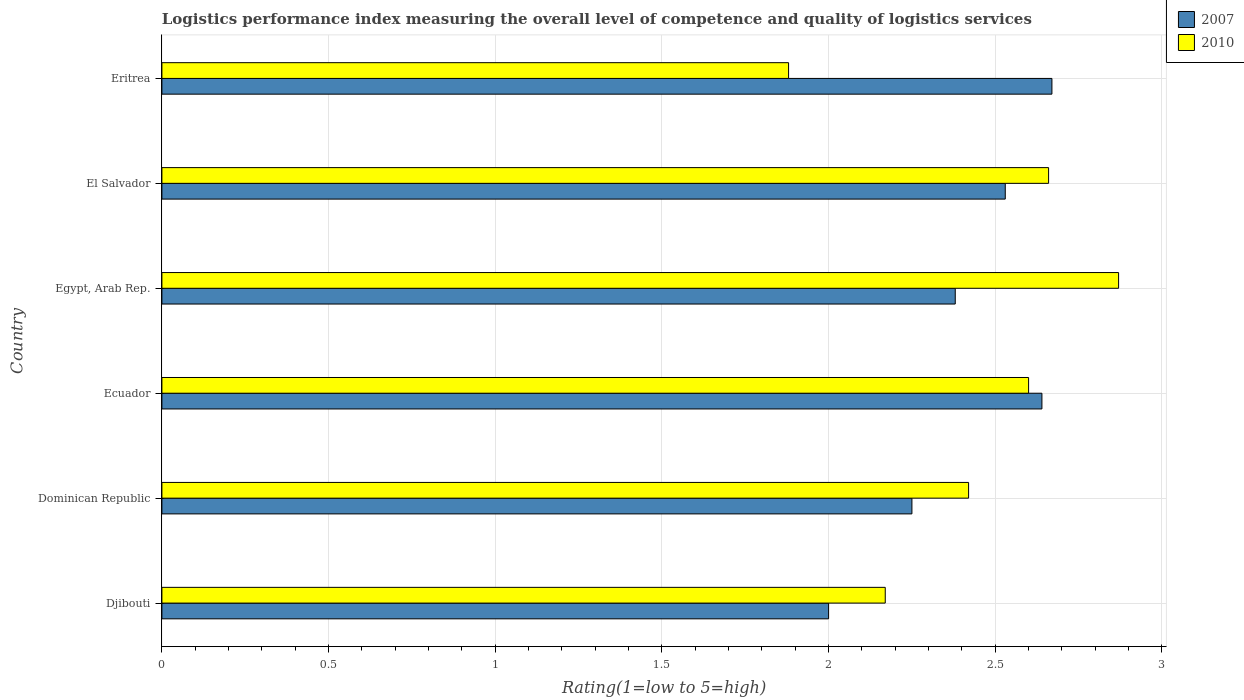How many bars are there on the 4th tick from the bottom?
Your response must be concise. 2. What is the label of the 2nd group of bars from the top?
Make the answer very short. El Salvador. In how many cases, is the number of bars for a given country not equal to the number of legend labels?
Keep it short and to the point. 0. What is the Logistic performance index in 2010 in Egypt, Arab Rep.?
Offer a very short reply. 2.87. Across all countries, what is the maximum Logistic performance index in 2007?
Give a very brief answer. 2.67. Across all countries, what is the minimum Logistic performance index in 2010?
Provide a succinct answer. 1.88. In which country was the Logistic performance index in 2007 maximum?
Offer a very short reply. Eritrea. In which country was the Logistic performance index in 2007 minimum?
Keep it short and to the point. Djibouti. What is the total Logistic performance index in 2010 in the graph?
Make the answer very short. 14.6. What is the difference between the Logistic performance index in 2007 in Djibouti and that in El Salvador?
Offer a terse response. -0.53. What is the difference between the Logistic performance index in 2007 in Eritrea and the Logistic performance index in 2010 in Ecuador?
Your response must be concise. 0.07. What is the average Logistic performance index in 2007 per country?
Ensure brevity in your answer.  2.41. What is the difference between the Logistic performance index in 2010 and Logistic performance index in 2007 in Egypt, Arab Rep.?
Provide a short and direct response. 0.49. In how many countries, is the Logistic performance index in 2010 greater than 2.7 ?
Your answer should be very brief. 1. What is the ratio of the Logistic performance index in 2007 in Dominican Republic to that in El Salvador?
Your answer should be very brief. 0.89. Is the Logistic performance index in 2007 in Djibouti less than that in Eritrea?
Offer a terse response. Yes. What is the difference between the highest and the second highest Logistic performance index in 2010?
Make the answer very short. 0.21. What is the difference between the highest and the lowest Logistic performance index in 2007?
Give a very brief answer. 0.67. What does the 1st bar from the bottom in Dominican Republic represents?
Make the answer very short. 2007. How many bars are there?
Ensure brevity in your answer.  12. Are all the bars in the graph horizontal?
Keep it short and to the point. Yes. How many countries are there in the graph?
Provide a short and direct response. 6. What is the difference between two consecutive major ticks on the X-axis?
Ensure brevity in your answer.  0.5. Are the values on the major ticks of X-axis written in scientific E-notation?
Provide a short and direct response. No. What is the title of the graph?
Keep it short and to the point. Logistics performance index measuring the overall level of competence and quality of logistics services. What is the label or title of the X-axis?
Provide a short and direct response. Rating(1=low to 5=high). What is the Rating(1=low to 5=high) of 2007 in Djibouti?
Make the answer very short. 2. What is the Rating(1=low to 5=high) in 2010 in Djibouti?
Your answer should be compact. 2.17. What is the Rating(1=low to 5=high) in 2007 in Dominican Republic?
Provide a short and direct response. 2.25. What is the Rating(1=low to 5=high) in 2010 in Dominican Republic?
Your answer should be compact. 2.42. What is the Rating(1=low to 5=high) in 2007 in Ecuador?
Your answer should be very brief. 2.64. What is the Rating(1=low to 5=high) in 2007 in Egypt, Arab Rep.?
Offer a very short reply. 2.38. What is the Rating(1=low to 5=high) in 2010 in Egypt, Arab Rep.?
Offer a very short reply. 2.87. What is the Rating(1=low to 5=high) of 2007 in El Salvador?
Offer a very short reply. 2.53. What is the Rating(1=low to 5=high) of 2010 in El Salvador?
Ensure brevity in your answer.  2.66. What is the Rating(1=low to 5=high) of 2007 in Eritrea?
Your response must be concise. 2.67. What is the Rating(1=low to 5=high) in 2010 in Eritrea?
Keep it short and to the point. 1.88. Across all countries, what is the maximum Rating(1=low to 5=high) in 2007?
Your answer should be compact. 2.67. Across all countries, what is the maximum Rating(1=low to 5=high) in 2010?
Your response must be concise. 2.87. Across all countries, what is the minimum Rating(1=low to 5=high) in 2010?
Your answer should be very brief. 1.88. What is the total Rating(1=low to 5=high) in 2007 in the graph?
Your answer should be very brief. 14.47. What is the total Rating(1=low to 5=high) in 2010 in the graph?
Ensure brevity in your answer.  14.6. What is the difference between the Rating(1=low to 5=high) of 2007 in Djibouti and that in Dominican Republic?
Your answer should be very brief. -0.25. What is the difference between the Rating(1=low to 5=high) in 2007 in Djibouti and that in Ecuador?
Your answer should be very brief. -0.64. What is the difference between the Rating(1=low to 5=high) of 2010 in Djibouti and that in Ecuador?
Keep it short and to the point. -0.43. What is the difference between the Rating(1=low to 5=high) of 2007 in Djibouti and that in Egypt, Arab Rep.?
Your answer should be compact. -0.38. What is the difference between the Rating(1=low to 5=high) of 2010 in Djibouti and that in Egypt, Arab Rep.?
Offer a terse response. -0.7. What is the difference between the Rating(1=low to 5=high) of 2007 in Djibouti and that in El Salvador?
Your answer should be compact. -0.53. What is the difference between the Rating(1=low to 5=high) in 2010 in Djibouti and that in El Salvador?
Give a very brief answer. -0.49. What is the difference between the Rating(1=low to 5=high) of 2007 in Djibouti and that in Eritrea?
Provide a succinct answer. -0.67. What is the difference between the Rating(1=low to 5=high) in 2010 in Djibouti and that in Eritrea?
Offer a terse response. 0.29. What is the difference between the Rating(1=low to 5=high) of 2007 in Dominican Republic and that in Ecuador?
Give a very brief answer. -0.39. What is the difference between the Rating(1=low to 5=high) of 2010 in Dominican Republic and that in Ecuador?
Keep it short and to the point. -0.18. What is the difference between the Rating(1=low to 5=high) in 2007 in Dominican Republic and that in Egypt, Arab Rep.?
Your response must be concise. -0.13. What is the difference between the Rating(1=low to 5=high) in 2010 in Dominican Republic and that in Egypt, Arab Rep.?
Your answer should be compact. -0.45. What is the difference between the Rating(1=low to 5=high) of 2007 in Dominican Republic and that in El Salvador?
Offer a very short reply. -0.28. What is the difference between the Rating(1=low to 5=high) of 2010 in Dominican Republic and that in El Salvador?
Your answer should be very brief. -0.24. What is the difference between the Rating(1=low to 5=high) of 2007 in Dominican Republic and that in Eritrea?
Ensure brevity in your answer.  -0.42. What is the difference between the Rating(1=low to 5=high) of 2010 in Dominican Republic and that in Eritrea?
Your response must be concise. 0.54. What is the difference between the Rating(1=low to 5=high) of 2007 in Ecuador and that in Egypt, Arab Rep.?
Offer a terse response. 0.26. What is the difference between the Rating(1=low to 5=high) of 2010 in Ecuador and that in Egypt, Arab Rep.?
Offer a very short reply. -0.27. What is the difference between the Rating(1=low to 5=high) of 2007 in Ecuador and that in El Salvador?
Ensure brevity in your answer.  0.11. What is the difference between the Rating(1=low to 5=high) in 2010 in Ecuador and that in El Salvador?
Make the answer very short. -0.06. What is the difference between the Rating(1=low to 5=high) in 2007 in Ecuador and that in Eritrea?
Your answer should be very brief. -0.03. What is the difference between the Rating(1=low to 5=high) in 2010 in Ecuador and that in Eritrea?
Offer a terse response. 0.72. What is the difference between the Rating(1=low to 5=high) of 2010 in Egypt, Arab Rep. and that in El Salvador?
Offer a very short reply. 0.21. What is the difference between the Rating(1=low to 5=high) in 2007 in Egypt, Arab Rep. and that in Eritrea?
Your answer should be compact. -0.29. What is the difference between the Rating(1=low to 5=high) in 2007 in El Salvador and that in Eritrea?
Offer a very short reply. -0.14. What is the difference between the Rating(1=low to 5=high) in 2010 in El Salvador and that in Eritrea?
Provide a short and direct response. 0.78. What is the difference between the Rating(1=low to 5=high) in 2007 in Djibouti and the Rating(1=low to 5=high) in 2010 in Dominican Republic?
Provide a short and direct response. -0.42. What is the difference between the Rating(1=low to 5=high) of 2007 in Djibouti and the Rating(1=low to 5=high) of 2010 in Egypt, Arab Rep.?
Ensure brevity in your answer.  -0.87. What is the difference between the Rating(1=low to 5=high) in 2007 in Djibouti and the Rating(1=low to 5=high) in 2010 in El Salvador?
Provide a succinct answer. -0.66. What is the difference between the Rating(1=low to 5=high) in 2007 in Djibouti and the Rating(1=low to 5=high) in 2010 in Eritrea?
Your answer should be compact. 0.12. What is the difference between the Rating(1=low to 5=high) of 2007 in Dominican Republic and the Rating(1=low to 5=high) of 2010 in Ecuador?
Offer a terse response. -0.35. What is the difference between the Rating(1=low to 5=high) in 2007 in Dominican Republic and the Rating(1=low to 5=high) in 2010 in Egypt, Arab Rep.?
Your answer should be compact. -0.62. What is the difference between the Rating(1=low to 5=high) in 2007 in Dominican Republic and the Rating(1=low to 5=high) in 2010 in El Salvador?
Make the answer very short. -0.41. What is the difference between the Rating(1=low to 5=high) of 2007 in Dominican Republic and the Rating(1=low to 5=high) of 2010 in Eritrea?
Your answer should be compact. 0.37. What is the difference between the Rating(1=low to 5=high) of 2007 in Ecuador and the Rating(1=low to 5=high) of 2010 in Egypt, Arab Rep.?
Provide a succinct answer. -0.23. What is the difference between the Rating(1=low to 5=high) in 2007 in Ecuador and the Rating(1=low to 5=high) in 2010 in El Salvador?
Your answer should be very brief. -0.02. What is the difference between the Rating(1=low to 5=high) of 2007 in Ecuador and the Rating(1=low to 5=high) of 2010 in Eritrea?
Provide a short and direct response. 0.76. What is the difference between the Rating(1=low to 5=high) of 2007 in Egypt, Arab Rep. and the Rating(1=low to 5=high) of 2010 in El Salvador?
Offer a terse response. -0.28. What is the difference between the Rating(1=low to 5=high) in 2007 in Egypt, Arab Rep. and the Rating(1=low to 5=high) in 2010 in Eritrea?
Ensure brevity in your answer.  0.5. What is the difference between the Rating(1=low to 5=high) of 2007 in El Salvador and the Rating(1=low to 5=high) of 2010 in Eritrea?
Ensure brevity in your answer.  0.65. What is the average Rating(1=low to 5=high) of 2007 per country?
Keep it short and to the point. 2.41. What is the average Rating(1=low to 5=high) of 2010 per country?
Ensure brevity in your answer.  2.43. What is the difference between the Rating(1=low to 5=high) in 2007 and Rating(1=low to 5=high) in 2010 in Djibouti?
Your response must be concise. -0.17. What is the difference between the Rating(1=low to 5=high) of 2007 and Rating(1=low to 5=high) of 2010 in Dominican Republic?
Provide a succinct answer. -0.17. What is the difference between the Rating(1=low to 5=high) of 2007 and Rating(1=low to 5=high) of 2010 in Ecuador?
Ensure brevity in your answer.  0.04. What is the difference between the Rating(1=low to 5=high) in 2007 and Rating(1=low to 5=high) in 2010 in Egypt, Arab Rep.?
Provide a short and direct response. -0.49. What is the difference between the Rating(1=low to 5=high) in 2007 and Rating(1=low to 5=high) in 2010 in El Salvador?
Your answer should be compact. -0.13. What is the difference between the Rating(1=low to 5=high) in 2007 and Rating(1=low to 5=high) in 2010 in Eritrea?
Keep it short and to the point. 0.79. What is the ratio of the Rating(1=low to 5=high) of 2010 in Djibouti to that in Dominican Republic?
Keep it short and to the point. 0.9. What is the ratio of the Rating(1=low to 5=high) of 2007 in Djibouti to that in Ecuador?
Ensure brevity in your answer.  0.76. What is the ratio of the Rating(1=low to 5=high) of 2010 in Djibouti to that in Ecuador?
Ensure brevity in your answer.  0.83. What is the ratio of the Rating(1=low to 5=high) in 2007 in Djibouti to that in Egypt, Arab Rep.?
Your answer should be compact. 0.84. What is the ratio of the Rating(1=low to 5=high) of 2010 in Djibouti to that in Egypt, Arab Rep.?
Your response must be concise. 0.76. What is the ratio of the Rating(1=low to 5=high) of 2007 in Djibouti to that in El Salvador?
Your response must be concise. 0.79. What is the ratio of the Rating(1=low to 5=high) of 2010 in Djibouti to that in El Salvador?
Give a very brief answer. 0.82. What is the ratio of the Rating(1=low to 5=high) of 2007 in Djibouti to that in Eritrea?
Give a very brief answer. 0.75. What is the ratio of the Rating(1=low to 5=high) of 2010 in Djibouti to that in Eritrea?
Ensure brevity in your answer.  1.15. What is the ratio of the Rating(1=low to 5=high) in 2007 in Dominican Republic to that in Ecuador?
Your answer should be very brief. 0.85. What is the ratio of the Rating(1=low to 5=high) of 2010 in Dominican Republic to that in Ecuador?
Make the answer very short. 0.93. What is the ratio of the Rating(1=low to 5=high) in 2007 in Dominican Republic to that in Egypt, Arab Rep.?
Provide a succinct answer. 0.95. What is the ratio of the Rating(1=low to 5=high) in 2010 in Dominican Republic to that in Egypt, Arab Rep.?
Your response must be concise. 0.84. What is the ratio of the Rating(1=low to 5=high) of 2007 in Dominican Republic to that in El Salvador?
Keep it short and to the point. 0.89. What is the ratio of the Rating(1=low to 5=high) in 2010 in Dominican Republic to that in El Salvador?
Give a very brief answer. 0.91. What is the ratio of the Rating(1=low to 5=high) of 2007 in Dominican Republic to that in Eritrea?
Your answer should be very brief. 0.84. What is the ratio of the Rating(1=low to 5=high) in 2010 in Dominican Republic to that in Eritrea?
Keep it short and to the point. 1.29. What is the ratio of the Rating(1=low to 5=high) in 2007 in Ecuador to that in Egypt, Arab Rep.?
Provide a succinct answer. 1.11. What is the ratio of the Rating(1=low to 5=high) in 2010 in Ecuador to that in Egypt, Arab Rep.?
Offer a very short reply. 0.91. What is the ratio of the Rating(1=low to 5=high) of 2007 in Ecuador to that in El Salvador?
Keep it short and to the point. 1.04. What is the ratio of the Rating(1=low to 5=high) in 2010 in Ecuador to that in El Salvador?
Provide a succinct answer. 0.98. What is the ratio of the Rating(1=low to 5=high) in 2007 in Ecuador to that in Eritrea?
Ensure brevity in your answer.  0.99. What is the ratio of the Rating(1=low to 5=high) in 2010 in Ecuador to that in Eritrea?
Ensure brevity in your answer.  1.38. What is the ratio of the Rating(1=low to 5=high) of 2007 in Egypt, Arab Rep. to that in El Salvador?
Make the answer very short. 0.94. What is the ratio of the Rating(1=low to 5=high) in 2010 in Egypt, Arab Rep. to that in El Salvador?
Your response must be concise. 1.08. What is the ratio of the Rating(1=low to 5=high) of 2007 in Egypt, Arab Rep. to that in Eritrea?
Offer a terse response. 0.89. What is the ratio of the Rating(1=low to 5=high) of 2010 in Egypt, Arab Rep. to that in Eritrea?
Your answer should be compact. 1.53. What is the ratio of the Rating(1=low to 5=high) in 2007 in El Salvador to that in Eritrea?
Your answer should be very brief. 0.95. What is the ratio of the Rating(1=low to 5=high) of 2010 in El Salvador to that in Eritrea?
Your answer should be compact. 1.41. What is the difference between the highest and the second highest Rating(1=low to 5=high) in 2007?
Give a very brief answer. 0.03. What is the difference between the highest and the second highest Rating(1=low to 5=high) of 2010?
Your answer should be very brief. 0.21. What is the difference between the highest and the lowest Rating(1=low to 5=high) in 2007?
Provide a succinct answer. 0.67. 